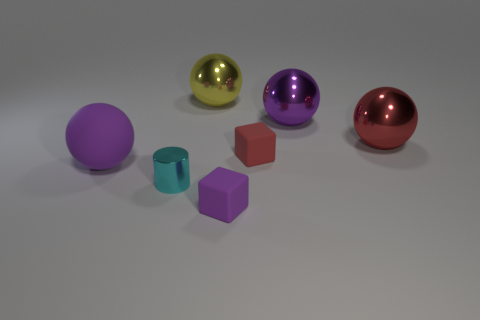How many other things are there of the same material as the large red thing?
Give a very brief answer. 3. Do the purple rubber object behind the small shiny cylinder and the tiny purple object have the same shape?
Offer a very short reply. No. Do the tiny metal cylinder and the matte ball have the same color?
Offer a very short reply. No. What number of objects are purple rubber objects on the right side of the cyan thing or small red matte cubes?
Ensure brevity in your answer.  2. There is a purple object that is the same size as the cyan shiny object; what is its shape?
Keep it short and to the point. Cube. There is a block that is on the left side of the small red rubber cube; is it the same size as the purple ball that is on the right side of the purple matte sphere?
Offer a terse response. No. The small cylinder that is made of the same material as the large yellow thing is what color?
Make the answer very short. Cyan. Does the purple ball on the left side of the cyan object have the same material as the purple sphere that is on the right side of the yellow shiny ball?
Your answer should be very brief. No. Is there a block of the same size as the cyan cylinder?
Your response must be concise. Yes. There is a purple thing that is in front of the cyan metallic thing left of the red shiny thing; what is its size?
Provide a short and direct response. Small. 